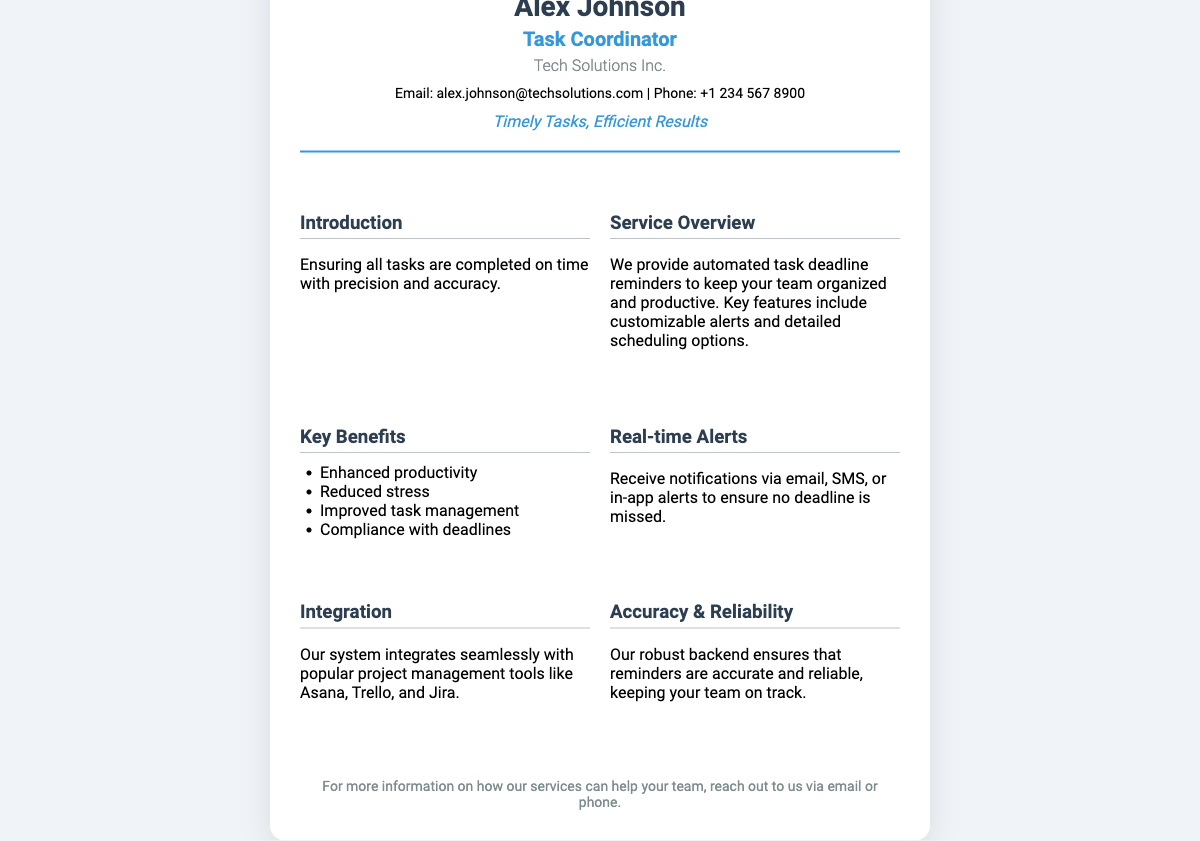What is the name of the task coordinator? The name is listed prominently at the top of the business card.
Answer: Alex Johnson What is the email address of Alex Johnson? The email address is provided under the contact section of the business card.
Answer: alex.johnson@techsolutions.com What company does Alex Johnson work for? The company name is displayed in the business card details.
Answer: Tech Solutions Inc What is the main service provided? A brief description of the service is provided in the service overview section.
Answer: Automated task deadline reminders What are two key benefits listed? The benefits are listed in the key benefits section of the card.
Answer: Enhanced productivity, Reduced stress How can notifications be received? The details about notifications are provided in the real-time alerts section.
Answer: Email, SMS, or in-app alerts Which project management tools does the system integrate with? The integration section mentions specific tools related to project management.
Answer: Asana, Trello, and Jira What is the slogan on the business card? The slogan is showcased prominently below the contact information.
Answer: Timely Tasks, Efficient Results What is the focus of the task coordinator's introduction? The introduction describes the primary responsibility mentioned on the card.
Answer: Ensuring all tasks are completed on time 